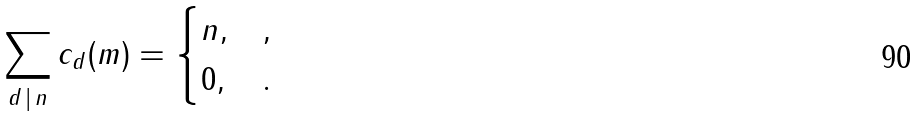Convert formula to latex. <formula><loc_0><loc_0><loc_500><loc_500>\sum _ { d \, | \, n } c _ { d } ( m ) & = \begin{cases} n , & , \\ 0 , & . \end{cases}</formula> 